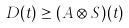<formula> <loc_0><loc_0><loc_500><loc_500>D ( t ) \geq ( A \otimes S ) ( t )</formula> 